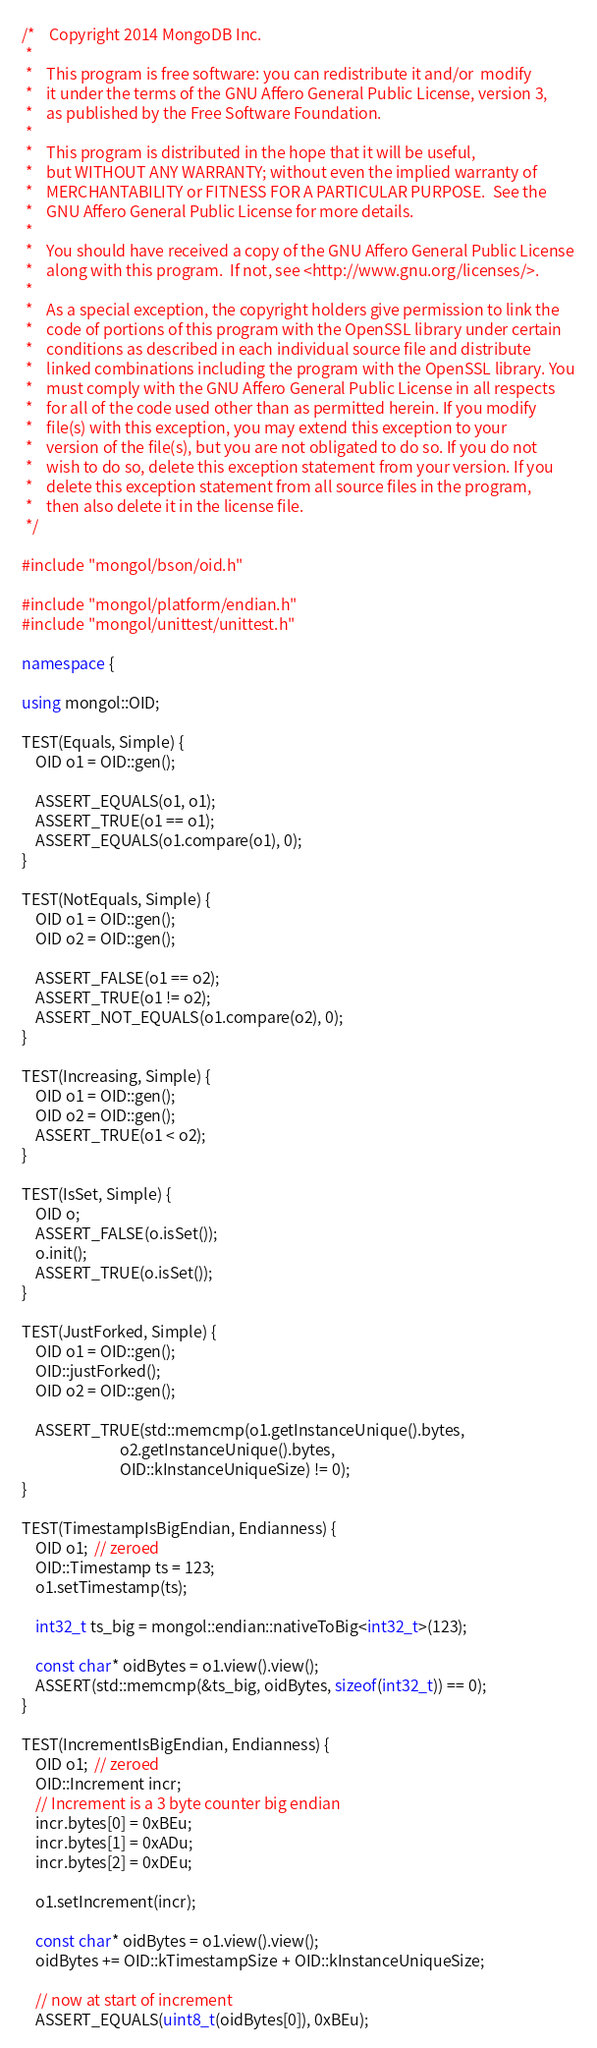Convert code to text. <code><loc_0><loc_0><loc_500><loc_500><_C++_>/*    Copyright 2014 MongoDB Inc.
 *
 *    This program is free software: you can redistribute it and/or  modify
 *    it under the terms of the GNU Affero General Public License, version 3,
 *    as published by the Free Software Foundation.
 *
 *    This program is distributed in the hope that it will be useful,
 *    but WITHOUT ANY WARRANTY; without even the implied warranty of
 *    MERCHANTABILITY or FITNESS FOR A PARTICULAR PURPOSE.  See the
 *    GNU Affero General Public License for more details.
 *
 *    You should have received a copy of the GNU Affero General Public License
 *    along with this program.  If not, see <http://www.gnu.org/licenses/>.
 *
 *    As a special exception, the copyright holders give permission to link the
 *    code of portions of this program with the OpenSSL library under certain
 *    conditions as described in each individual source file and distribute
 *    linked combinations including the program with the OpenSSL library. You
 *    must comply with the GNU Affero General Public License in all respects
 *    for all of the code used other than as permitted herein. If you modify
 *    file(s) with this exception, you may extend this exception to your
 *    version of the file(s), but you are not obligated to do so. If you do not
 *    wish to do so, delete this exception statement from your version. If you
 *    delete this exception statement from all source files in the program,
 *    then also delete it in the license file.
 */

#include "mongol/bson/oid.h"

#include "mongol/platform/endian.h"
#include "mongol/unittest/unittest.h"

namespace {

using mongol::OID;

TEST(Equals, Simple) {
    OID o1 = OID::gen();

    ASSERT_EQUALS(o1, o1);
    ASSERT_TRUE(o1 == o1);
    ASSERT_EQUALS(o1.compare(o1), 0);
}

TEST(NotEquals, Simple) {
    OID o1 = OID::gen();
    OID o2 = OID::gen();

    ASSERT_FALSE(o1 == o2);
    ASSERT_TRUE(o1 != o2);
    ASSERT_NOT_EQUALS(o1.compare(o2), 0);
}

TEST(Increasing, Simple) {
    OID o1 = OID::gen();
    OID o2 = OID::gen();
    ASSERT_TRUE(o1 < o2);
}

TEST(IsSet, Simple) {
    OID o;
    ASSERT_FALSE(o.isSet());
    o.init();
    ASSERT_TRUE(o.isSet());
}

TEST(JustForked, Simple) {
    OID o1 = OID::gen();
    OID::justForked();
    OID o2 = OID::gen();

    ASSERT_TRUE(std::memcmp(o1.getInstanceUnique().bytes,
                            o2.getInstanceUnique().bytes,
                            OID::kInstanceUniqueSize) != 0);
}

TEST(TimestampIsBigEndian, Endianness) {
    OID o1;  // zeroed
    OID::Timestamp ts = 123;
    o1.setTimestamp(ts);

    int32_t ts_big = mongol::endian::nativeToBig<int32_t>(123);

    const char* oidBytes = o1.view().view();
    ASSERT(std::memcmp(&ts_big, oidBytes, sizeof(int32_t)) == 0);
}

TEST(IncrementIsBigEndian, Endianness) {
    OID o1;  // zeroed
    OID::Increment incr;
    // Increment is a 3 byte counter big endian
    incr.bytes[0] = 0xBEu;
    incr.bytes[1] = 0xADu;
    incr.bytes[2] = 0xDEu;

    o1.setIncrement(incr);

    const char* oidBytes = o1.view().view();
    oidBytes += OID::kTimestampSize + OID::kInstanceUniqueSize;

    // now at start of increment
    ASSERT_EQUALS(uint8_t(oidBytes[0]), 0xBEu);</code> 